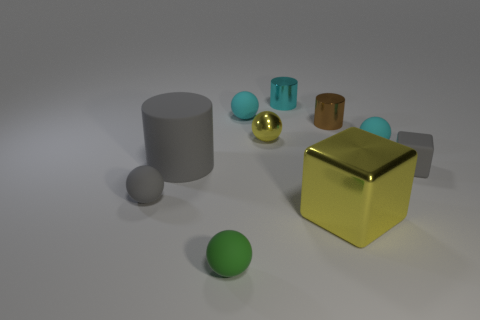Subtract all small green spheres. How many spheres are left? 4 Subtract all yellow cubes. How many cubes are left? 1 Subtract all cyan cylinders. How many gray balls are left? 1 Subtract 2 cylinders. How many cylinders are left? 1 Subtract all small gray rubber spheres. Subtract all small shiny balls. How many objects are left? 8 Add 9 cyan cylinders. How many cyan cylinders are left? 10 Add 7 yellow shiny objects. How many yellow shiny objects exist? 9 Subtract 1 gray cylinders. How many objects are left? 9 Subtract all cubes. How many objects are left? 8 Subtract all blue blocks. Subtract all yellow balls. How many blocks are left? 2 